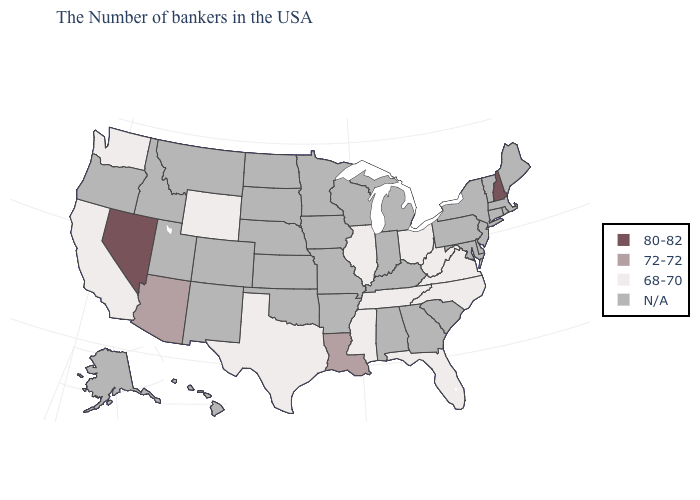What is the value of Montana?
Be succinct. N/A. Which states have the lowest value in the USA?
Write a very short answer. Virginia, North Carolina, West Virginia, Ohio, Florida, Tennessee, Illinois, Mississippi, Texas, Wyoming, California, Washington. Name the states that have a value in the range 68-70?
Keep it brief. Virginia, North Carolina, West Virginia, Ohio, Florida, Tennessee, Illinois, Mississippi, Texas, Wyoming, California, Washington. Which states have the lowest value in the USA?
Be succinct. Virginia, North Carolina, West Virginia, Ohio, Florida, Tennessee, Illinois, Mississippi, Texas, Wyoming, California, Washington. Does New Hampshire have the lowest value in the USA?
Keep it brief. No. Name the states that have a value in the range 72-72?
Quick response, please. Louisiana, Arizona. Which states hav the highest value in the West?
Give a very brief answer. Nevada. What is the value of Rhode Island?
Concise answer only. N/A. What is the value of North Dakota?
Short answer required. N/A. Which states have the lowest value in the South?
Give a very brief answer. Virginia, North Carolina, West Virginia, Florida, Tennessee, Mississippi, Texas. What is the value of Arizona?
Keep it brief. 72-72. Among the states that border Arizona , which have the lowest value?
Short answer required. California. Which states have the lowest value in the USA?
Keep it brief. Virginia, North Carolina, West Virginia, Ohio, Florida, Tennessee, Illinois, Mississippi, Texas, Wyoming, California, Washington. 